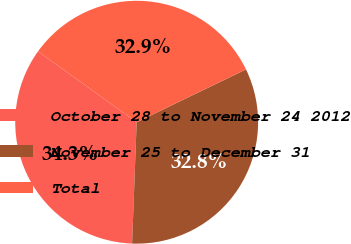Convert chart to OTSL. <chart><loc_0><loc_0><loc_500><loc_500><pie_chart><fcel>October 28 to November 24 2012<fcel>November 25 to December 31<fcel>Total<nl><fcel>34.32%<fcel>32.76%<fcel>32.92%<nl></chart> 